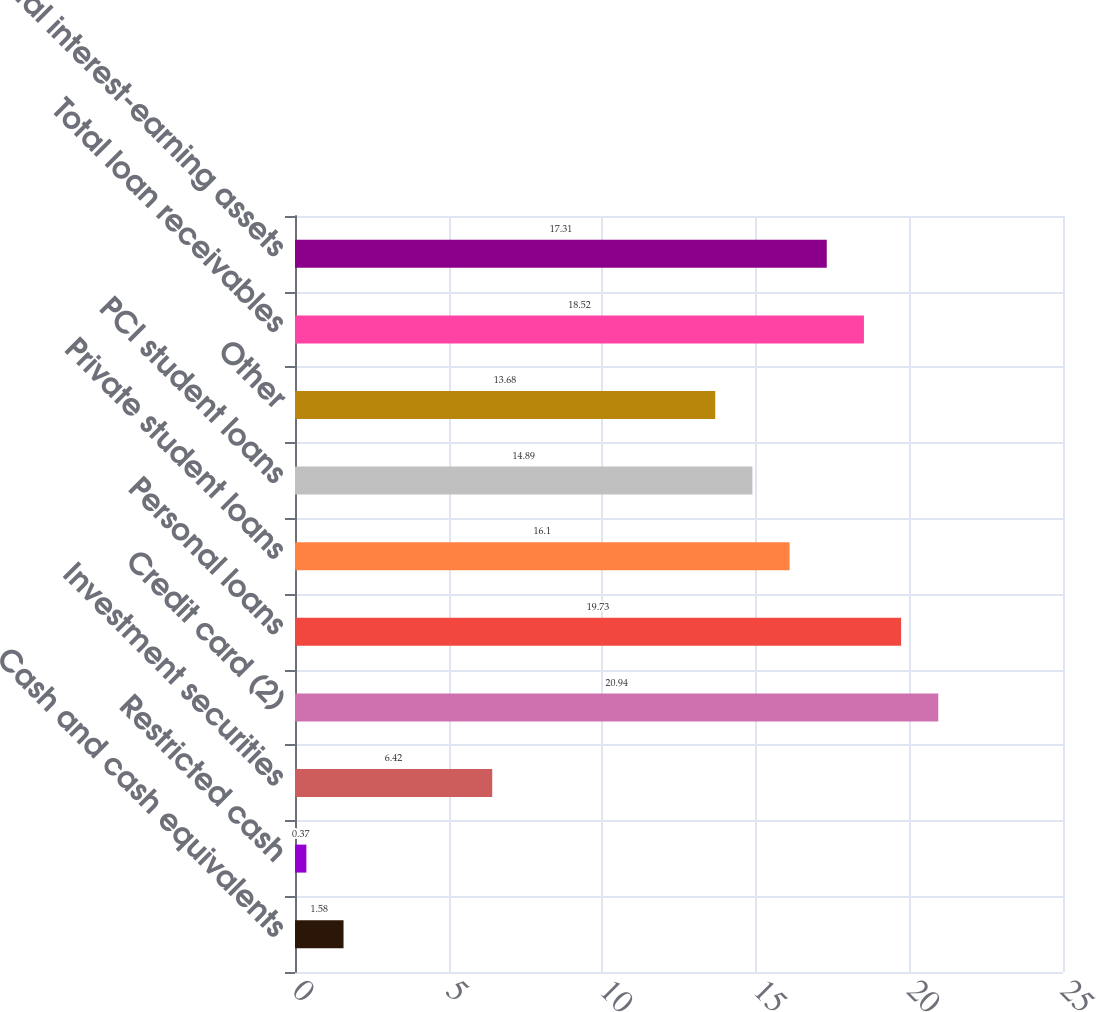Convert chart. <chart><loc_0><loc_0><loc_500><loc_500><bar_chart><fcel>Cash and cash equivalents<fcel>Restricted cash<fcel>Investment securities<fcel>Credit card (2)<fcel>Personal loans<fcel>Private student loans<fcel>PCI student loans<fcel>Other<fcel>Total loan receivables<fcel>Total interest-earning assets<nl><fcel>1.58<fcel>0.37<fcel>6.42<fcel>20.94<fcel>19.73<fcel>16.1<fcel>14.89<fcel>13.68<fcel>18.52<fcel>17.31<nl></chart> 